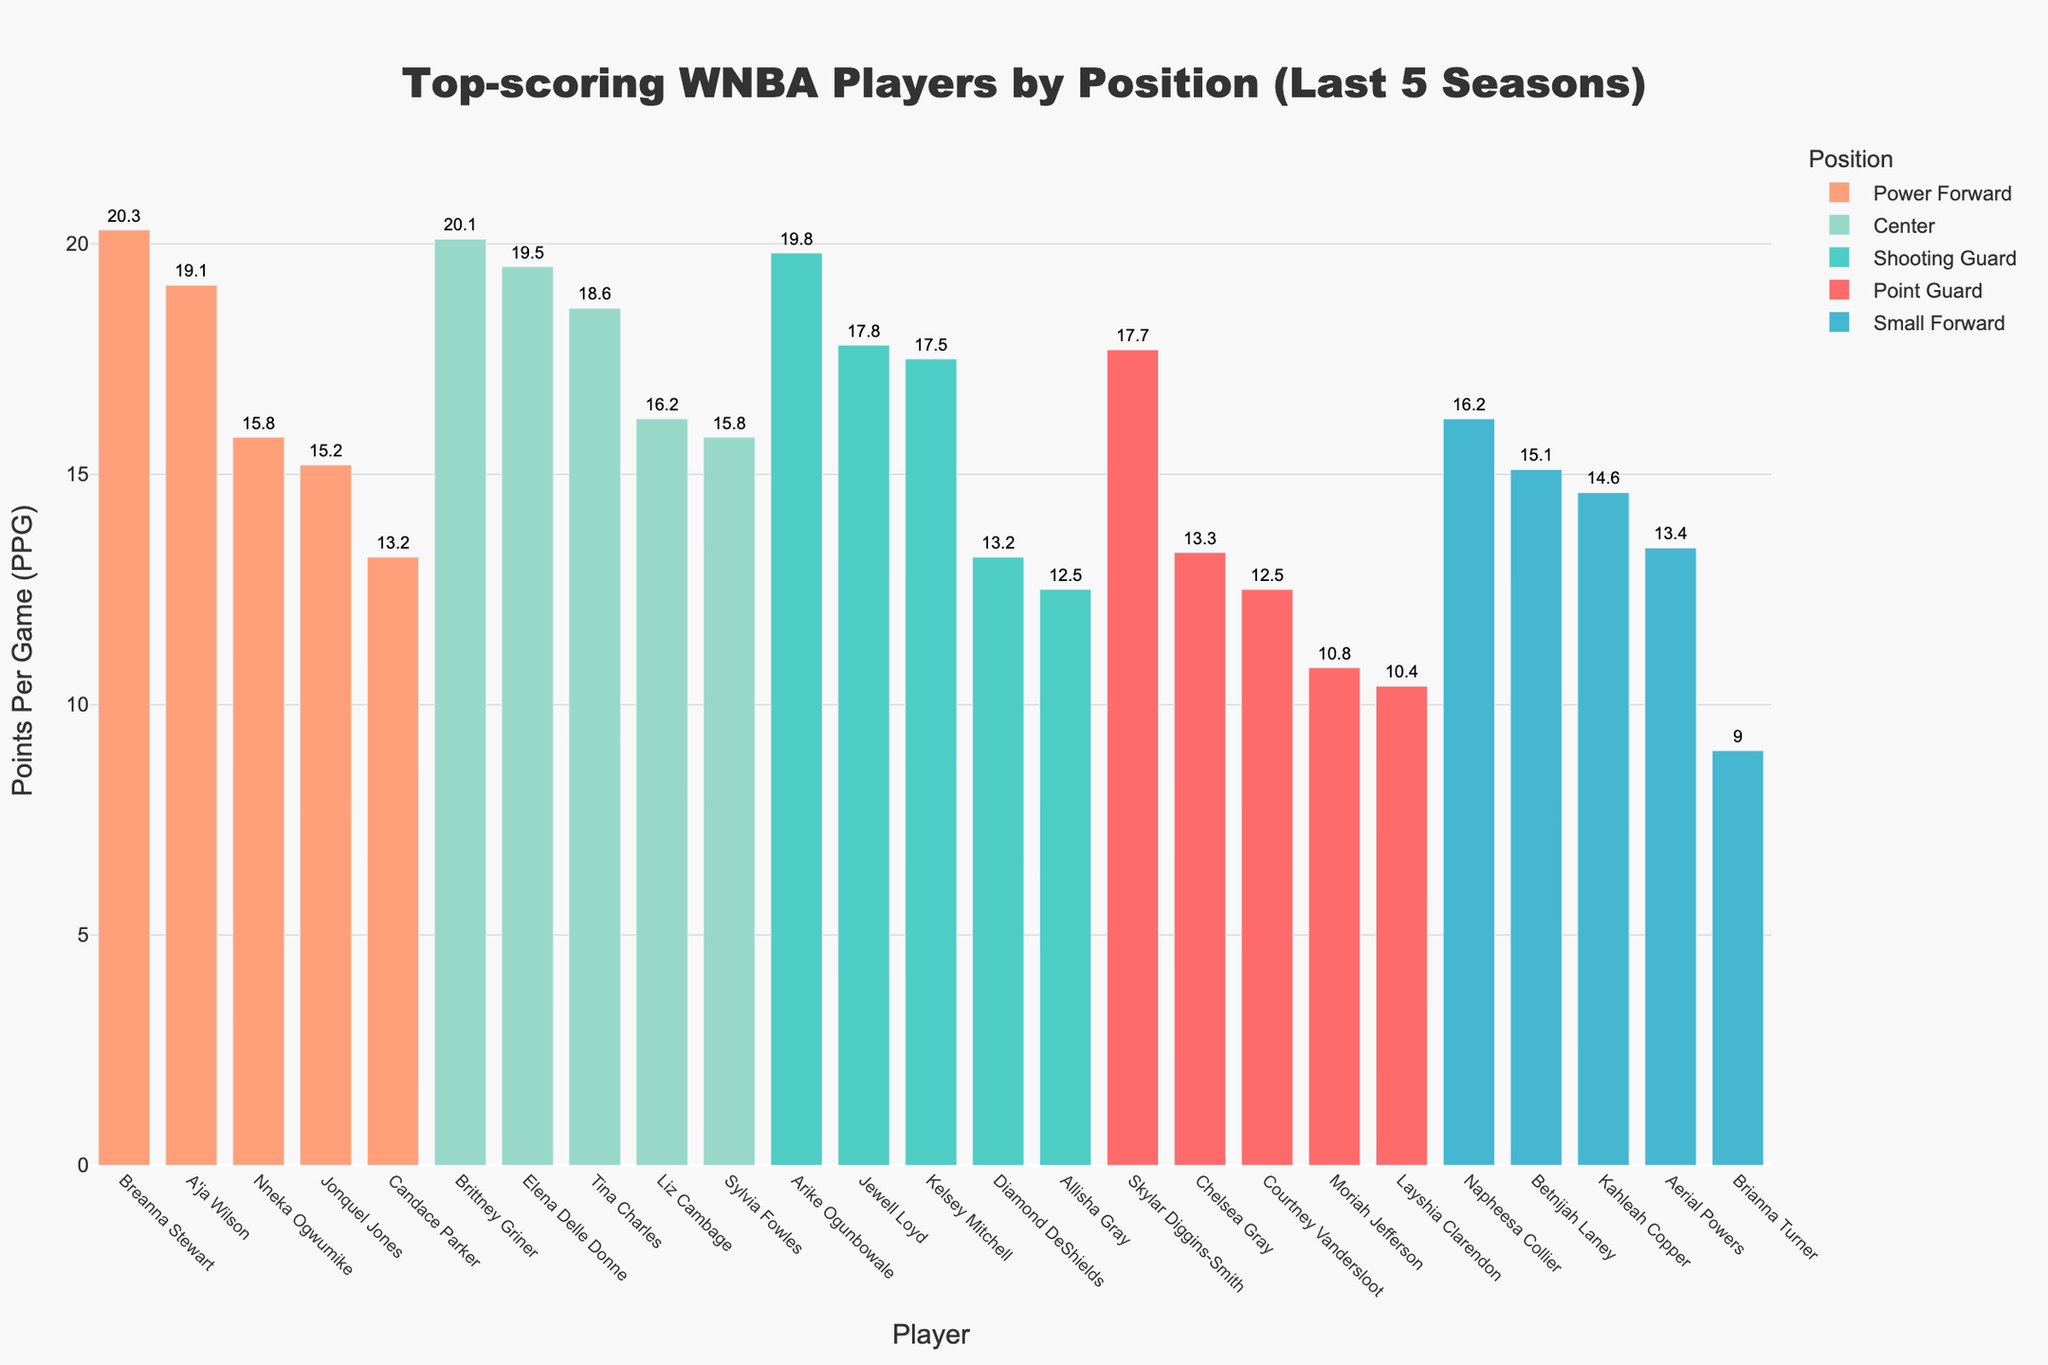Which point guard has the highest PPG? Skylar Diggins-Smith has the highest PPG among point guards. By looking at the red bars representing point guards, her bar is the tallest, indicating 17.7 PPG.
Answer: Skylar Diggins-Smith Who has a higher PPG, A'ja Wilson or Candace Parker? Comparing the orange bars for A'ja Wilson and Candace Parker, A'ja Wilson’s bar is taller at 19.1 PPG while Candace Parker’s is at 13.2 PPG.
Answer: A'ja Wilson What is the sum of PPGs for the top three scoring shooting guards? To find the sum, add the PPGs for Arike Ogunbowale (19.8), Jewell Loyd (17.8), and Kelsey Mitchell (17.5). 19.8 + 17.8 + 17.5 = 55.1
Answer: 55.1 What is the difference in PPG between Breanna Stewart and Jonquel Jones? Subtract Jonquel Jones' PPG (15.2) from Breanna Stewart's PPG (20.3): 20.3 - 15.2 = 5.1
Answer: 5.1 Is there any small forward with a PPG lower than 10? Among the blue bars representing small forwards, Brianna Turner has a PPG of 9.0, which is lower than 10.
Answer: Yes How many players have a PPG greater than 18? By counting the players with bars taller than the 18 PPG mark, there are 5 such players: Arike Ogunbowale (19.8), Breanna Stewart (20.3), Brittney Griner (20.1), Elena Delle Donne (19.5), and A'ja Wilson (19.1).
Answer: 5 Which position has the player with the highest PPG? Brittney Griner, holding the highest PPG of 20.1, is a center. This is evident by her bar being the tallest among purple bars representing centers.
Answer: Center 